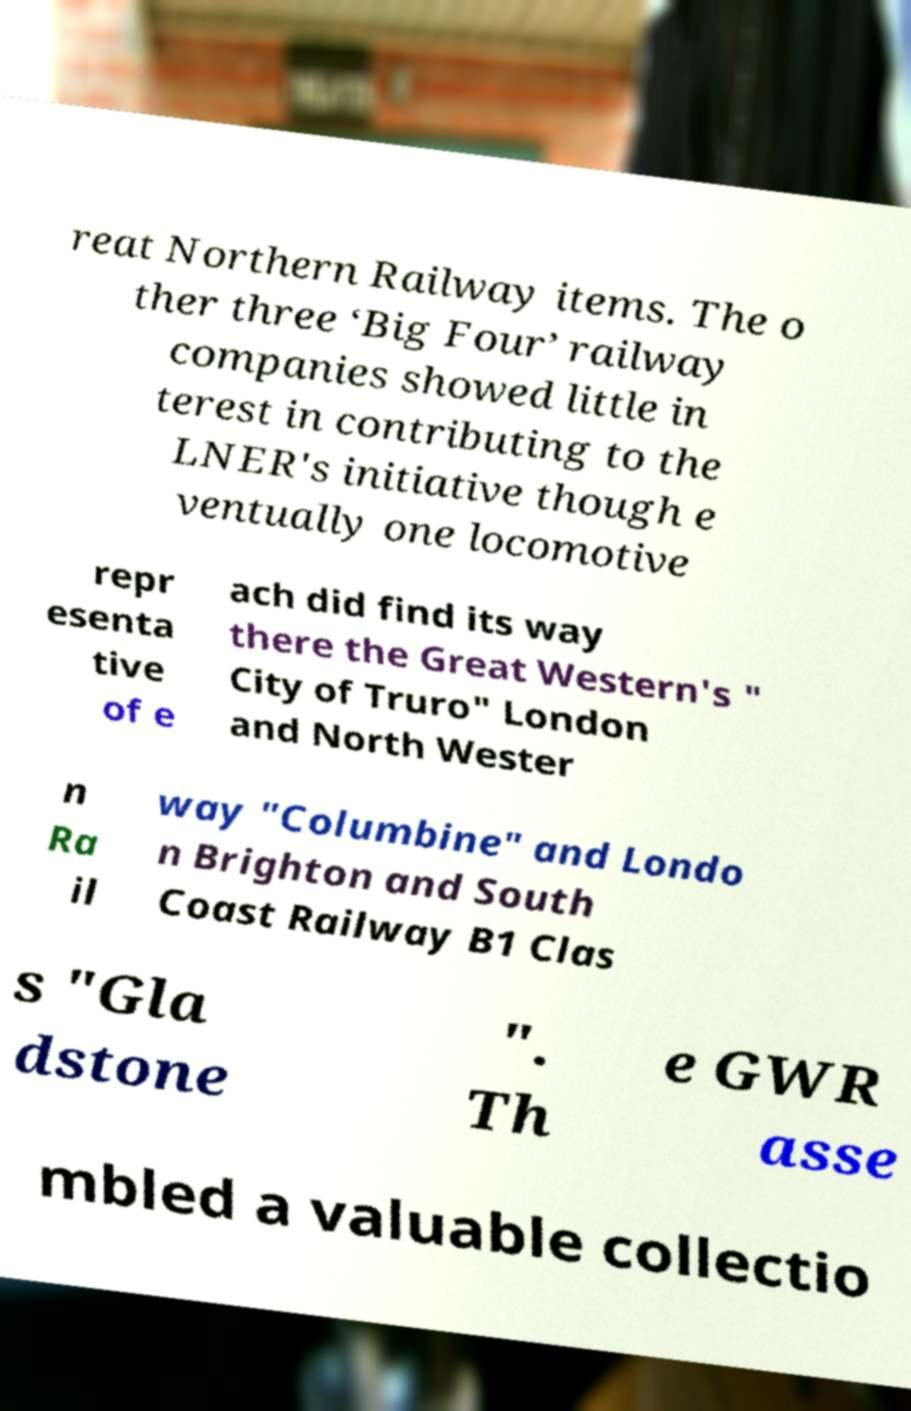Could you assist in decoding the text presented in this image and type it out clearly? reat Northern Railway items. The o ther three ‘Big Four’ railway companies showed little in terest in contributing to the LNER's initiative though e ventually one locomotive repr esenta tive of e ach did find its way there the Great Western's " City of Truro" London and North Wester n Ra il way "Columbine" and Londo n Brighton and South Coast Railway B1 Clas s "Gla dstone ". Th e GWR asse mbled a valuable collectio 